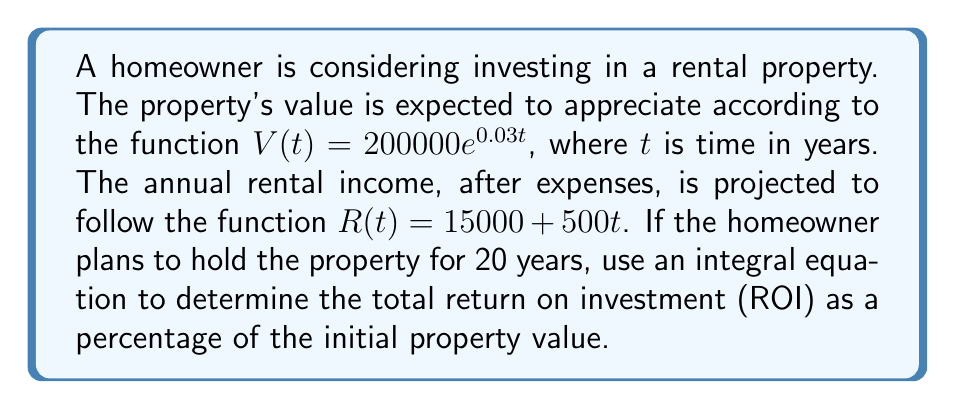Provide a solution to this math problem. To solve this problem, we'll follow these steps:

1) Calculate the initial property value:
   $V(0) = 200000e^{0.03 \cdot 0} = 200000$

2) Calculate the property value after 20 years:
   $V(20) = 200000e^{0.03 \cdot 20} = 200000e^{0.6} \approx 364538.77$

3) Calculate the total appreciation:
   $364538.77 - 200000 = 164538.77$

4) To find the total rental income, we need to integrate the rental income function over 20 years:
   $$\int_0^{20} (15000 + 500t) dt = [15000t + 250t^2]_0^{20}$$
   $$= (15000 \cdot 20 + 250 \cdot 20^2) - (15000 \cdot 0 + 250 \cdot 0^2)$$
   $$= 300000 + 100000 = 400000$$

5) Total return = Appreciation + Total Rental Income
   $164538.77 + 400000 = 564538.77$

6) ROI as a percentage:
   $\frac{564538.77}{200000} \cdot 100\% = 282.27\%$
Answer: 282.27% 